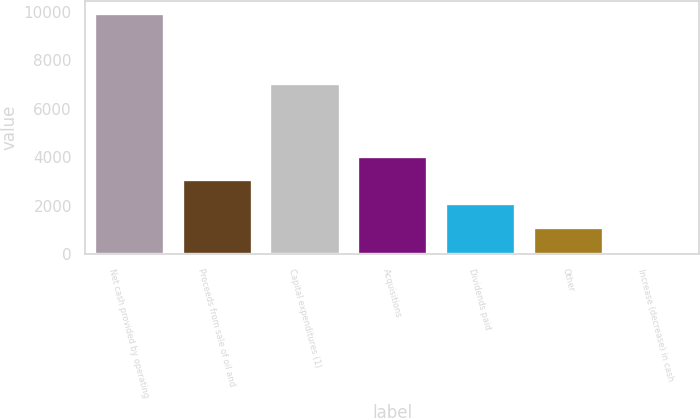<chart> <loc_0><loc_0><loc_500><loc_500><bar_chart><fcel>Net cash provided by operating<fcel>Proceeds from sale of oil and<fcel>Capital expenditures (1)<fcel>Acquisitions<fcel>Dividends paid<fcel>Other<fcel>Increase (decrease) in cash<nl><fcel>9953<fcel>3098.6<fcel>7078<fcel>4077.8<fcel>2119.4<fcel>1140.2<fcel>161<nl></chart> 